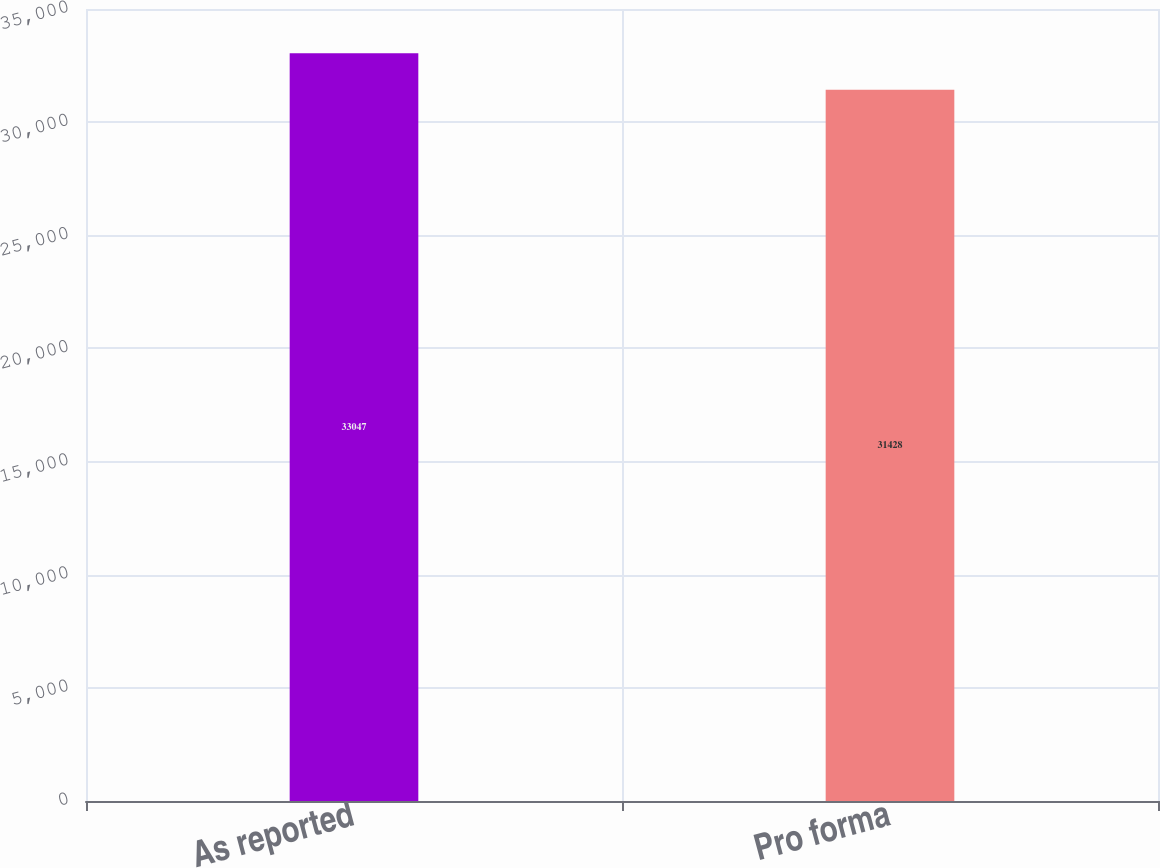<chart> <loc_0><loc_0><loc_500><loc_500><bar_chart><fcel>As reported<fcel>Pro forma<nl><fcel>33047<fcel>31428<nl></chart> 